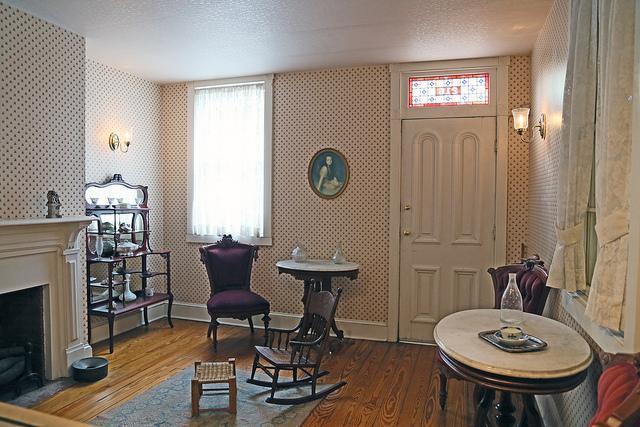How many chairs are in the picture?
Give a very brief answer. 3. 